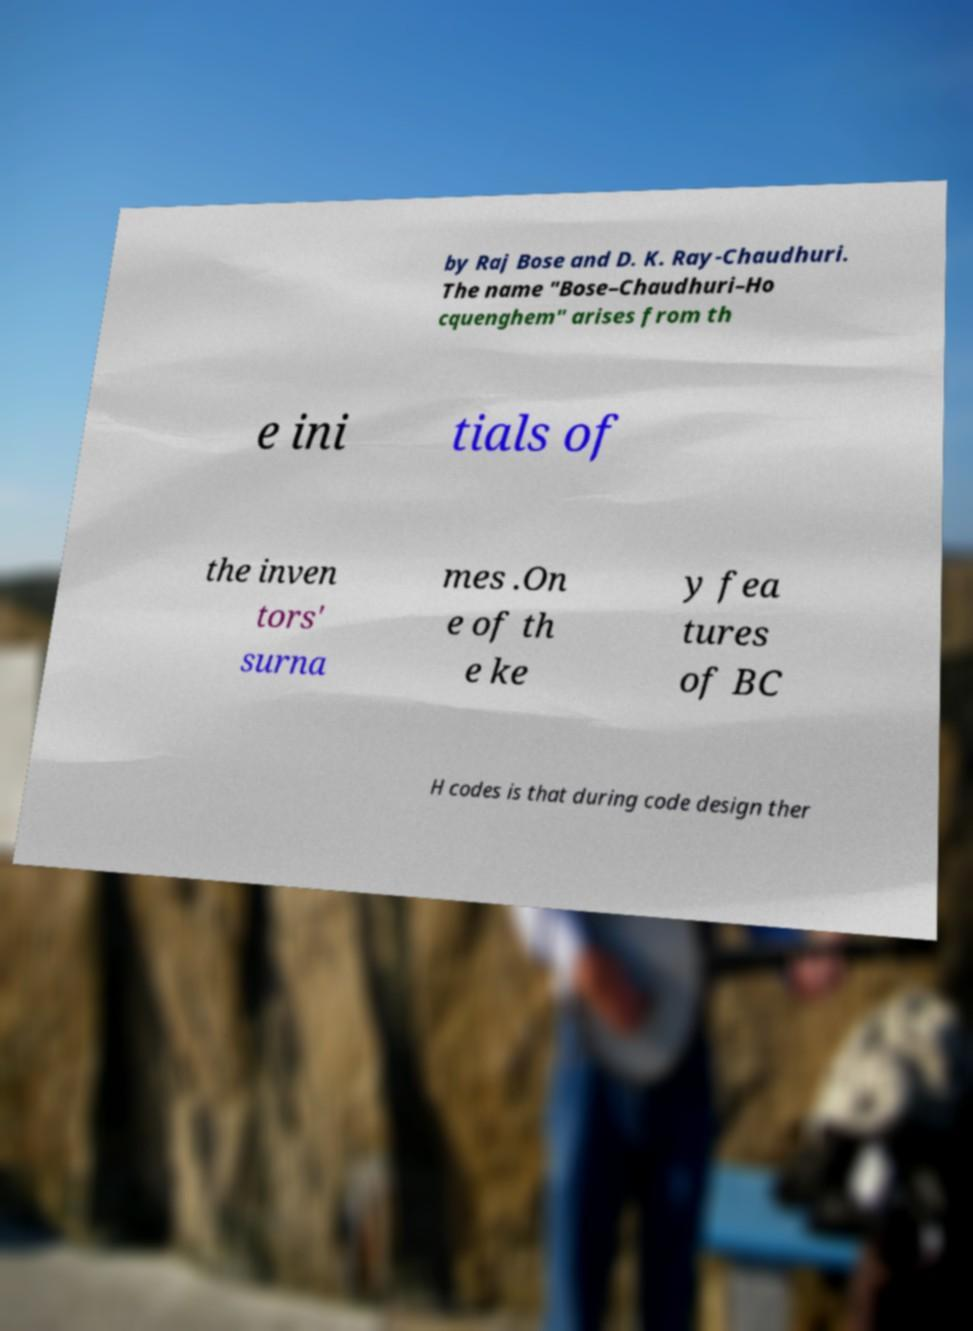Please read and relay the text visible in this image. What does it say? by Raj Bose and D. K. Ray-Chaudhuri. The name "Bose–Chaudhuri–Ho cquenghem" arises from th e ini tials of the inven tors' surna mes .On e of th e ke y fea tures of BC H codes is that during code design ther 